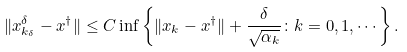Convert formula to latex. <formula><loc_0><loc_0><loc_500><loc_500>\| x _ { k _ { \delta } } ^ { \delta } - x ^ { \dag } \| \leq C \inf \left \{ \| x _ { k } - x ^ { \dag } \| + \frac { \delta } { \sqrt { \alpha _ { k } } } \colon k = 0 , 1 , \cdots \right \} .</formula> 